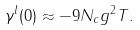<formula> <loc_0><loc_0><loc_500><loc_500>\gamma ^ { l } ( 0 ) \approx - 9 N _ { c } g ^ { 2 } T .</formula> 